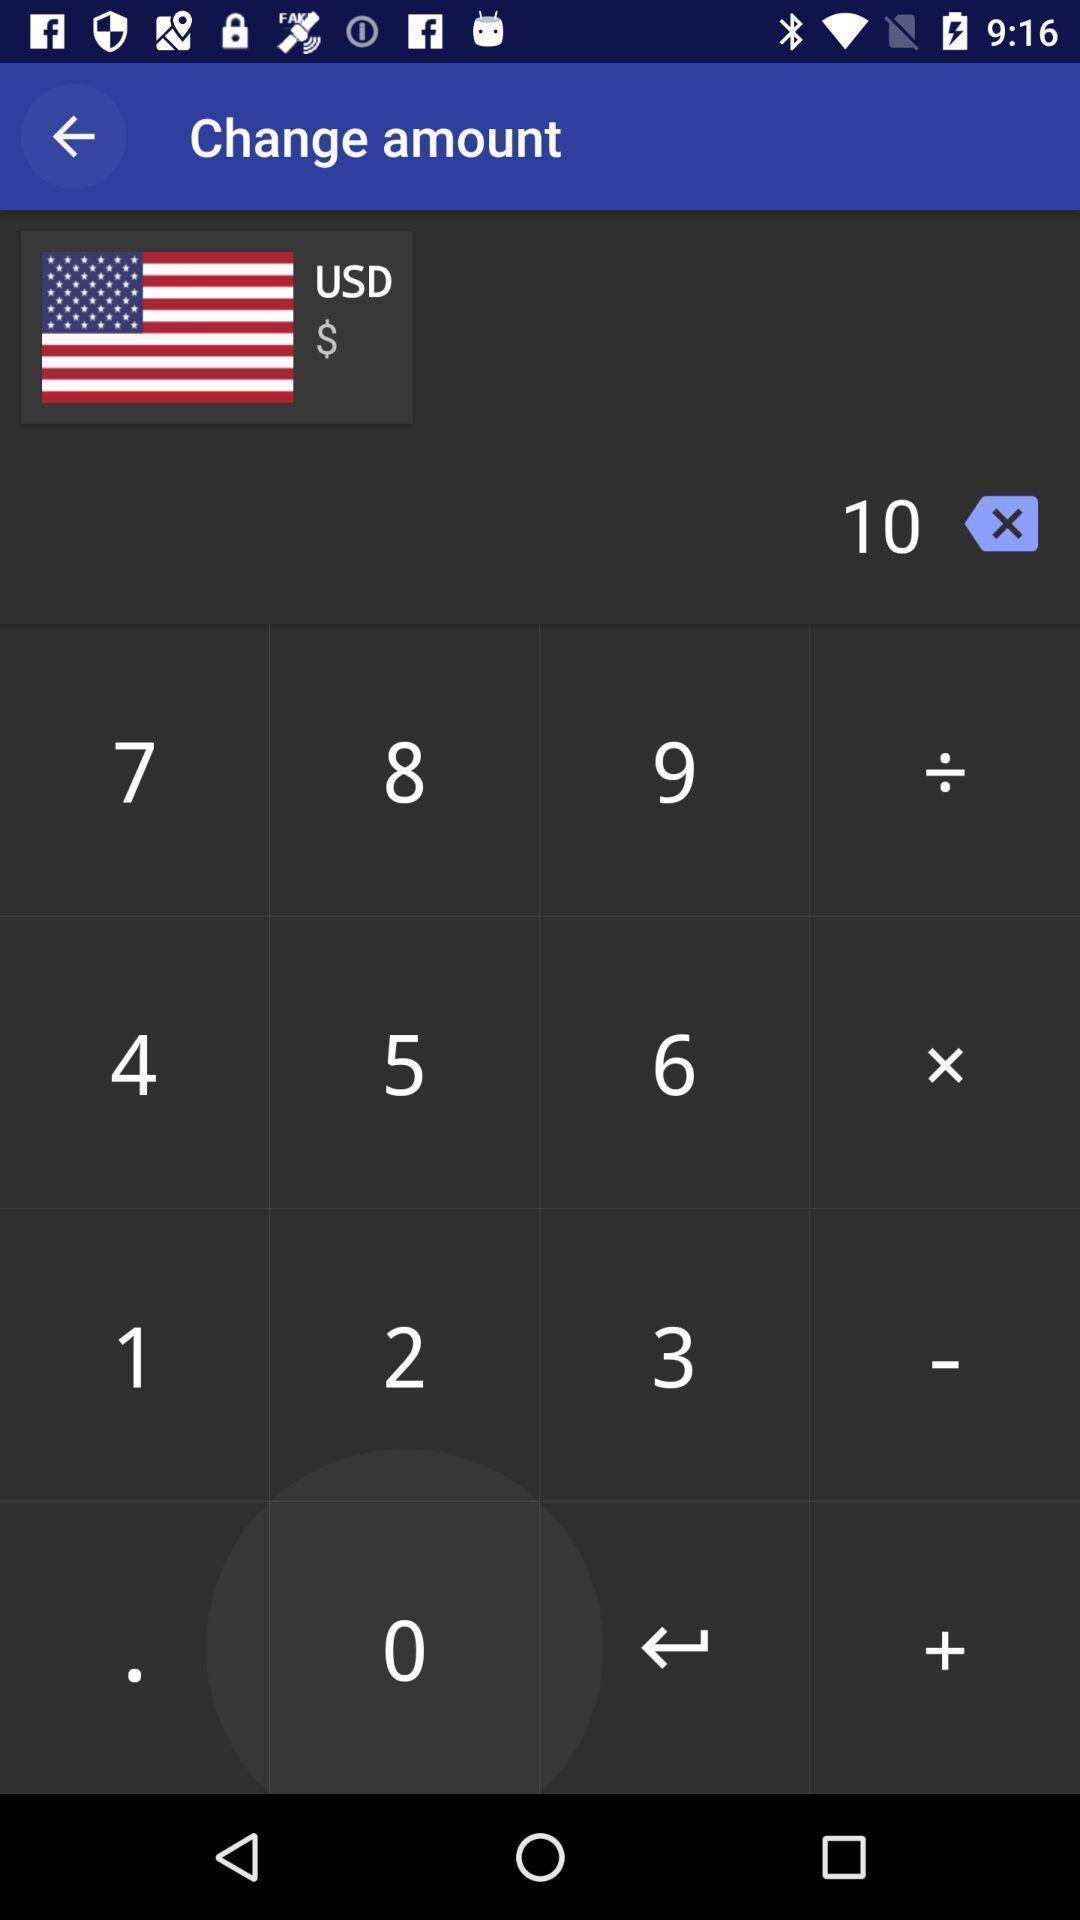Give me a narrative description of this picture. Screen shows a calculator on a device. 